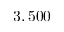Convert formula to latex. <formula><loc_0><loc_0><loc_500><loc_500>3 , 5 0 0</formula> 